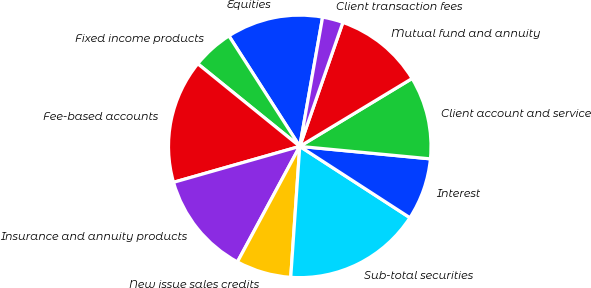<chart> <loc_0><loc_0><loc_500><loc_500><pie_chart><fcel>Equities<fcel>Fixed income products<fcel>Fee-based accounts<fcel>Insurance and annuity products<fcel>New issue sales credits<fcel>Sub-total securities<fcel>Interest<fcel>Client account and service<fcel>Mutual fund and annuity<fcel>Client transaction fees<nl><fcel>11.86%<fcel>5.09%<fcel>15.25%<fcel>12.71%<fcel>6.78%<fcel>16.95%<fcel>7.63%<fcel>10.17%<fcel>11.02%<fcel>2.54%<nl></chart> 